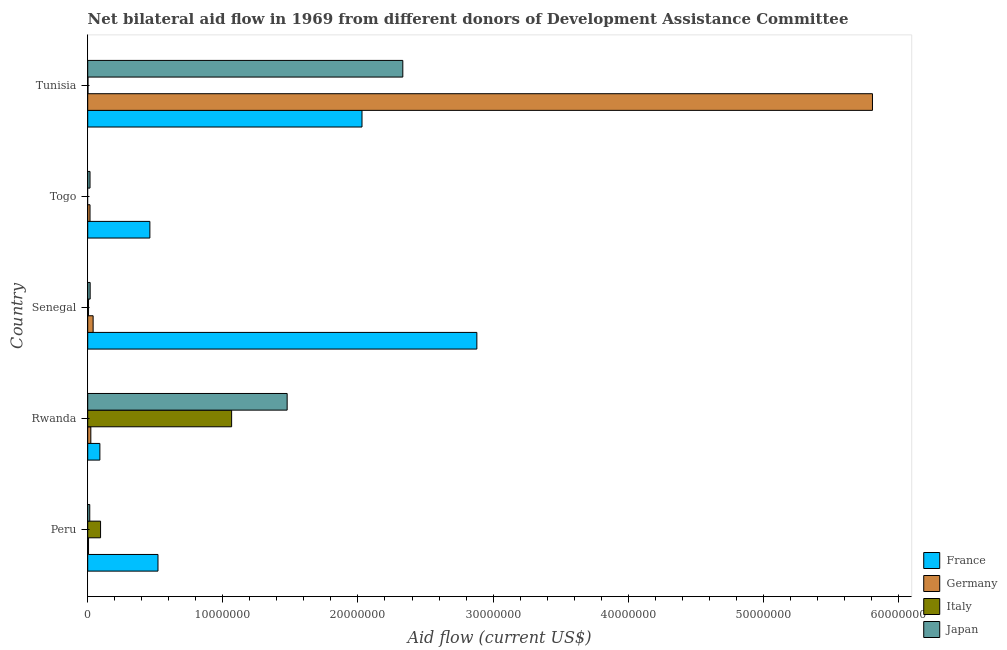How many groups of bars are there?
Your answer should be compact. 5. Are the number of bars per tick equal to the number of legend labels?
Make the answer very short. No. What is the label of the 4th group of bars from the top?
Provide a succinct answer. Rwanda. What is the amount of aid given by japan in Rwanda?
Make the answer very short. 1.48e+07. Across all countries, what is the maximum amount of aid given by japan?
Give a very brief answer. 2.33e+07. Across all countries, what is the minimum amount of aid given by france?
Your answer should be very brief. 9.00e+05. In which country was the amount of aid given by france maximum?
Keep it short and to the point. Senegal. What is the total amount of aid given by france in the graph?
Offer a very short reply. 5.98e+07. What is the difference between the amount of aid given by italy in Rwanda and that in Tunisia?
Your response must be concise. 1.06e+07. What is the difference between the amount of aid given by italy in Senegal and the amount of aid given by japan in Tunisia?
Give a very brief answer. -2.33e+07. What is the average amount of aid given by france per country?
Your answer should be very brief. 1.20e+07. What is the difference between the amount of aid given by japan and amount of aid given by germany in Tunisia?
Your answer should be compact. -3.48e+07. What is the ratio of the amount of aid given by japan in Senegal to that in Togo?
Keep it short and to the point. 1.06. Is the amount of aid given by japan in Senegal less than that in Tunisia?
Make the answer very short. Yes. What is the difference between the highest and the second highest amount of aid given by france?
Your answer should be very brief. 8.50e+06. What is the difference between the highest and the lowest amount of aid given by germany?
Offer a terse response. 5.80e+07. In how many countries, is the amount of aid given by germany greater than the average amount of aid given by germany taken over all countries?
Ensure brevity in your answer.  1. Is the sum of the amount of aid given by germany in Peru and Senegal greater than the maximum amount of aid given by japan across all countries?
Provide a succinct answer. No. Are all the bars in the graph horizontal?
Offer a terse response. Yes. How many countries are there in the graph?
Provide a short and direct response. 5. Does the graph contain grids?
Your answer should be compact. No. Where does the legend appear in the graph?
Your answer should be very brief. Bottom right. How are the legend labels stacked?
Your response must be concise. Vertical. What is the title of the graph?
Your answer should be compact. Net bilateral aid flow in 1969 from different donors of Development Assistance Committee. What is the label or title of the Y-axis?
Your answer should be very brief. Country. What is the Aid flow (current US$) of France in Peru?
Make the answer very short. 5.20e+06. What is the Aid flow (current US$) of Italy in Peru?
Offer a terse response. 9.50e+05. What is the Aid flow (current US$) of Japan in Peru?
Ensure brevity in your answer.  1.50e+05. What is the Aid flow (current US$) in France in Rwanda?
Offer a very short reply. 9.00e+05. What is the Aid flow (current US$) in Italy in Rwanda?
Your response must be concise. 1.06e+07. What is the Aid flow (current US$) in Japan in Rwanda?
Offer a terse response. 1.48e+07. What is the Aid flow (current US$) in France in Senegal?
Keep it short and to the point. 2.88e+07. What is the Aid flow (current US$) of Germany in Senegal?
Offer a terse response. 4.00e+05. What is the Aid flow (current US$) of France in Togo?
Offer a very short reply. 4.60e+06. What is the Aid flow (current US$) of Japan in Togo?
Offer a very short reply. 1.70e+05. What is the Aid flow (current US$) of France in Tunisia?
Provide a succinct answer. 2.03e+07. What is the Aid flow (current US$) of Germany in Tunisia?
Offer a terse response. 5.81e+07. What is the Aid flow (current US$) of Japan in Tunisia?
Make the answer very short. 2.33e+07. Across all countries, what is the maximum Aid flow (current US$) in France?
Keep it short and to the point. 2.88e+07. Across all countries, what is the maximum Aid flow (current US$) of Germany?
Provide a short and direct response. 5.81e+07. Across all countries, what is the maximum Aid flow (current US$) in Italy?
Ensure brevity in your answer.  1.06e+07. Across all countries, what is the maximum Aid flow (current US$) in Japan?
Make the answer very short. 2.33e+07. Across all countries, what is the minimum Aid flow (current US$) in France?
Give a very brief answer. 9.00e+05. Across all countries, what is the minimum Aid flow (current US$) in Germany?
Your answer should be compact. 6.00e+04. Across all countries, what is the minimum Aid flow (current US$) of Italy?
Your answer should be very brief. 0. What is the total Aid flow (current US$) in France in the graph?
Offer a terse response. 5.98e+07. What is the total Aid flow (current US$) of Germany in the graph?
Your answer should be very brief. 5.89e+07. What is the total Aid flow (current US$) of Italy in the graph?
Make the answer very short. 1.17e+07. What is the total Aid flow (current US$) in Japan in the graph?
Offer a terse response. 3.86e+07. What is the difference between the Aid flow (current US$) of France in Peru and that in Rwanda?
Offer a terse response. 4.30e+06. What is the difference between the Aid flow (current US$) in Italy in Peru and that in Rwanda?
Offer a very short reply. -9.70e+06. What is the difference between the Aid flow (current US$) in Japan in Peru and that in Rwanda?
Give a very brief answer. -1.46e+07. What is the difference between the Aid flow (current US$) in France in Peru and that in Senegal?
Offer a terse response. -2.36e+07. What is the difference between the Aid flow (current US$) in Italy in Peru and that in Senegal?
Your response must be concise. 8.90e+05. What is the difference between the Aid flow (current US$) of France in Peru and that in Togo?
Keep it short and to the point. 6.00e+05. What is the difference between the Aid flow (current US$) of Japan in Peru and that in Togo?
Offer a very short reply. -2.00e+04. What is the difference between the Aid flow (current US$) in France in Peru and that in Tunisia?
Give a very brief answer. -1.51e+07. What is the difference between the Aid flow (current US$) of Germany in Peru and that in Tunisia?
Provide a short and direct response. -5.80e+07. What is the difference between the Aid flow (current US$) of Italy in Peru and that in Tunisia?
Your answer should be compact. 9.30e+05. What is the difference between the Aid flow (current US$) in Japan in Peru and that in Tunisia?
Your response must be concise. -2.32e+07. What is the difference between the Aid flow (current US$) of France in Rwanda and that in Senegal?
Ensure brevity in your answer.  -2.79e+07. What is the difference between the Aid flow (current US$) in Italy in Rwanda and that in Senegal?
Give a very brief answer. 1.06e+07. What is the difference between the Aid flow (current US$) of Japan in Rwanda and that in Senegal?
Offer a terse response. 1.46e+07. What is the difference between the Aid flow (current US$) of France in Rwanda and that in Togo?
Provide a succinct answer. -3.70e+06. What is the difference between the Aid flow (current US$) of Japan in Rwanda and that in Togo?
Provide a short and direct response. 1.46e+07. What is the difference between the Aid flow (current US$) in France in Rwanda and that in Tunisia?
Offer a very short reply. -1.94e+07. What is the difference between the Aid flow (current US$) in Germany in Rwanda and that in Tunisia?
Your answer should be very brief. -5.78e+07. What is the difference between the Aid flow (current US$) in Italy in Rwanda and that in Tunisia?
Provide a succinct answer. 1.06e+07. What is the difference between the Aid flow (current US$) of Japan in Rwanda and that in Tunisia?
Offer a very short reply. -8.56e+06. What is the difference between the Aid flow (current US$) of France in Senegal and that in Togo?
Your answer should be compact. 2.42e+07. What is the difference between the Aid flow (current US$) in Germany in Senegal and that in Togo?
Your answer should be very brief. 2.30e+05. What is the difference between the Aid flow (current US$) of France in Senegal and that in Tunisia?
Offer a very short reply. 8.50e+06. What is the difference between the Aid flow (current US$) of Germany in Senegal and that in Tunisia?
Provide a succinct answer. -5.77e+07. What is the difference between the Aid flow (current US$) in Japan in Senegal and that in Tunisia?
Offer a very short reply. -2.31e+07. What is the difference between the Aid flow (current US$) in France in Togo and that in Tunisia?
Provide a short and direct response. -1.57e+07. What is the difference between the Aid flow (current US$) of Germany in Togo and that in Tunisia?
Your answer should be very brief. -5.79e+07. What is the difference between the Aid flow (current US$) of Japan in Togo and that in Tunisia?
Ensure brevity in your answer.  -2.32e+07. What is the difference between the Aid flow (current US$) of France in Peru and the Aid flow (current US$) of Germany in Rwanda?
Give a very brief answer. 4.97e+06. What is the difference between the Aid flow (current US$) in France in Peru and the Aid flow (current US$) in Italy in Rwanda?
Make the answer very short. -5.45e+06. What is the difference between the Aid flow (current US$) in France in Peru and the Aid flow (current US$) in Japan in Rwanda?
Keep it short and to the point. -9.56e+06. What is the difference between the Aid flow (current US$) in Germany in Peru and the Aid flow (current US$) in Italy in Rwanda?
Ensure brevity in your answer.  -1.06e+07. What is the difference between the Aid flow (current US$) of Germany in Peru and the Aid flow (current US$) of Japan in Rwanda?
Give a very brief answer. -1.47e+07. What is the difference between the Aid flow (current US$) in Italy in Peru and the Aid flow (current US$) in Japan in Rwanda?
Offer a terse response. -1.38e+07. What is the difference between the Aid flow (current US$) of France in Peru and the Aid flow (current US$) of Germany in Senegal?
Keep it short and to the point. 4.80e+06. What is the difference between the Aid flow (current US$) in France in Peru and the Aid flow (current US$) in Italy in Senegal?
Provide a succinct answer. 5.14e+06. What is the difference between the Aid flow (current US$) of France in Peru and the Aid flow (current US$) of Japan in Senegal?
Offer a very short reply. 5.02e+06. What is the difference between the Aid flow (current US$) in Germany in Peru and the Aid flow (current US$) in Japan in Senegal?
Your answer should be compact. -1.20e+05. What is the difference between the Aid flow (current US$) of Italy in Peru and the Aid flow (current US$) of Japan in Senegal?
Your answer should be compact. 7.70e+05. What is the difference between the Aid flow (current US$) of France in Peru and the Aid flow (current US$) of Germany in Togo?
Your answer should be very brief. 5.03e+06. What is the difference between the Aid flow (current US$) in France in Peru and the Aid flow (current US$) in Japan in Togo?
Your response must be concise. 5.03e+06. What is the difference between the Aid flow (current US$) of Italy in Peru and the Aid flow (current US$) of Japan in Togo?
Offer a very short reply. 7.80e+05. What is the difference between the Aid flow (current US$) in France in Peru and the Aid flow (current US$) in Germany in Tunisia?
Your answer should be very brief. -5.29e+07. What is the difference between the Aid flow (current US$) in France in Peru and the Aid flow (current US$) in Italy in Tunisia?
Your answer should be compact. 5.18e+06. What is the difference between the Aid flow (current US$) in France in Peru and the Aid flow (current US$) in Japan in Tunisia?
Offer a very short reply. -1.81e+07. What is the difference between the Aid flow (current US$) of Germany in Peru and the Aid flow (current US$) of Japan in Tunisia?
Keep it short and to the point. -2.33e+07. What is the difference between the Aid flow (current US$) of Italy in Peru and the Aid flow (current US$) of Japan in Tunisia?
Your answer should be very brief. -2.24e+07. What is the difference between the Aid flow (current US$) of France in Rwanda and the Aid flow (current US$) of Germany in Senegal?
Provide a succinct answer. 5.00e+05. What is the difference between the Aid flow (current US$) of France in Rwanda and the Aid flow (current US$) of Italy in Senegal?
Provide a succinct answer. 8.40e+05. What is the difference between the Aid flow (current US$) of France in Rwanda and the Aid flow (current US$) of Japan in Senegal?
Give a very brief answer. 7.20e+05. What is the difference between the Aid flow (current US$) of Italy in Rwanda and the Aid flow (current US$) of Japan in Senegal?
Provide a short and direct response. 1.05e+07. What is the difference between the Aid flow (current US$) of France in Rwanda and the Aid flow (current US$) of Germany in Togo?
Provide a succinct answer. 7.30e+05. What is the difference between the Aid flow (current US$) in France in Rwanda and the Aid flow (current US$) in Japan in Togo?
Give a very brief answer. 7.30e+05. What is the difference between the Aid flow (current US$) of Germany in Rwanda and the Aid flow (current US$) of Japan in Togo?
Provide a succinct answer. 6.00e+04. What is the difference between the Aid flow (current US$) of Italy in Rwanda and the Aid flow (current US$) of Japan in Togo?
Provide a short and direct response. 1.05e+07. What is the difference between the Aid flow (current US$) of France in Rwanda and the Aid flow (current US$) of Germany in Tunisia?
Your answer should be compact. -5.72e+07. What is the difference between the Aid flow (current US$) of France in Rwanda and the Aid flow (current US$) of Italy in Tunisia?
Provide a short and direct response. 8.80e+05. What is the difference between the Aid flow (current US$) in France in Rwanda and the Aid flow (current US$) in Japan in Tunisia?
Your answer should be very brief. -2.24e+07. What is the difference between the Aid flow (current US$) of Germany in Rwanda and the Aid flow (current US$) of Japan in Tunisia?
Provide a succinct answer. -2.31e+07. What is the difference between the Aid flow (current US$) of Italy in Rwanda and the Aid flow (current US$) of Japan in Tunisia?
Offer a very short reply. -1.27e+07. What is the difference between the Aid flow (current US$) in France in Senegal and the Aid flow (current US$) in Germany in Togo?
Make the answer very short. 2.86e+07. What is the difference between the Aid flow (current US$) of France in Senegal and the Aid flow (current US$) of Japan in Togo?
Your response must be concise. 2.86e+07. What is the difference between the Aid flow (current US$) of Germany in Senegal and the Aid flow (current US$) of Japan in Togo?
Offer a very short reply. 2.30e+05. What is the difference between the Aid flow (current US$) in Italy in Senegal and the Aid flow (current US$) in Japan in Togo?
Give a very brief answer. -1.10e+05. What is the difference between the Aid flow (current US$) in France in Senegal and the Aid flow (current US$) in Germany in Tunisia?
Your response must be concise. -2.93e+07. What is the difference between the Aid flow (current US$) of France in Senegal and the Aid flow (current US$) of Italy in Tunisia?
Make the answer very short. 2.88e+07. What is the difference between the Aid flow (current US$) of France in Senegal and the Aid flow (current US$) of Japan in Tunisia?
Your answer should be compact. 5.48e+06. What is the difference between the Aid flow (current US$) of Germany in Senegal and the Aid flow (current US$) of Japan in Tunisia?
Your answer should be compact. -2.29e+07. What is the difference between the Aid flow (current US$) of Italy in Senegal and the Aid flow (current US$) of Japan in Tunisia?
Keep it short and to the point. -2.33e+07. What is the difference between the Aid flow (current US$) of France in Togo and the Aid flow (current US$) of Germany in Tunisia?
Make the answer very short. -5.35e+07. What is the difference between the Aid flow (current US$) of France in Togo and the Aid flow (current US$) of Italy in Tunisia?
Provide a short and direct response. 4.58e+06. What is the difference between the Aid flow (current US$) of France in Togo and the Aid flow (current US$) of Japan in Tunisia?
Offer a very short reply. -1.87e+07. What is the difference between the Aid flow (current US$) of Germany in Togo and the Aid flow (current US$) of Japan in Tunisia?
Ensure brevity in your answer.  -2.32e+07. What is the average Aid flow (current US$) of France per country?
Offer a very short reply. 1.20e+07. What is the average Aid flow (current US$) in Germany per country?
Keep it short and to the point. 1.18e+07. What is the average Aid flow (current US$) of Italy per country?
Ensure brevity in your answer.  2.34e+06. What is the average Aid flow (current US$) in Japan per country?
Your answer should be compact. 7.72e+06. What is the difference between the Aid flow (current US$) of France and Aid flow (current US$) of Germany in Peru?
Make the answer very short. 5.14e+06. What is the difference between the Aid flow (current US$) of France and Aid flow (current US$) of Italy in Peru?
Your response must be concise. 4.25e+06. What is the difference between the Aid flow (current US$) in France and Aid flow (current US$) in Japan in Peru?
Make the answer very short. 5.05e+06. What is the difference between the Aid flow (current US$) of Germany and Aid flow (current US$) of Italy in Peru?
Offer a very short reply. -8.90e+05. What is the difference between the Aid flow (current US$) in Italy and Aid flow (current US$) in Japan in Peru?
Keep it short and to the point. 8.00e+05. What is the difference between the Aid flow (current US$) of France and Aid flow (current US$) of Germany in Rwanda?
Offer a terse response. 6.70e+05. What is the difference between the Aid flow (current US$) in France and Aid flow (current US$) in Italy in Rwanda?
Provide a short and direct response. -9.75e+06. What is the difference between the Aid flow (current US$) in France and Aid flow (current US$) in Japan in Rwanda?
Provide a short and direct response. -1.39e+07. What is the difference between the Aid flow (current US$) in Germany and Aid flow (current US$) in Italy in Rwanda?
Give a very brief answer. -1.04e+07. What is the difference between the Aid flow (current US$) in Germany and Aid flow (current US$) in Japan in Rwanda?
Provide a succinct answer. -1.45e+07. What is the difference between the Aid flow (current US$) of Italy and Aid flow (current US$) of Japan in Rwanda?
Ensure brevity in your answer.  -4.11e+06. What is the difference between the Aid flow (current US$) of France and Aid flow (current US$) of Germany in Senegal?
Ensure brevity in your answer.  2.84e+07. What is the difference between the Aid flow (current US$) of France and Aid flow (current US$) of Italy in Senegal?
Your answer should be very brief. 2.87e+07. What is the difference between the Aid flow (current US$) of France and Aid flow (current US$) of Japan in Senegal?
Ensure brevity in your answer.  2.86e+07. What is the difference between the Aid flow (current US$) of Germany and Aid flow (current US$) of Italy in Senegal?
Give a very brief answer. 3.40e+05. What is the difference between the Aid flow (current US$) of Germany and Aid flow (current US$) of Japan in Senegal?
Ensure brevity in your answer.  2.20e+05. What is the difference between the Aid flow (current US$) of Italy and Aid flow (current US$) of Japan in Senegal?
Keep it short and to the point. -1.20e+05. What is the difference between the Aid flow (current US$) of France and Aid flow (current US$) of Germany in Togo?
Your answer should be very brief. 4.43e+06. What is the difference between the Aid flow (current US$) in France and Aid flow (current US$) in Japan in Togo?
Your answer should be very brief. 4.43e+06. What is the difference between the Aid flow (current US$) of Germany and Aid flow (current US$) of Japan in Togo?
Offer a terse response. 0. What is the difference between the Aid flow (current US$) in France and Aid flow (current US$) in Germany in Tunisia?
Your answer should be compact. -3.78e+07. What is the difference between the Aid flow (current US$) of France and Aid flow (current US$) of Italy in Tunisia?
Provide a short and direct response. 2.03e+07. What is the difference between the Aid flow (current US$) in France and Aid flow (current US$) in Japan in Tunisia?
Make the answer very short. -3.02e+06. What is the difference between the Aid flow (current US$) of Germany and Aid flow (current US$) of Italy in Tunisia?
Your answer should be compact. 5.81e+07. What is the difference between the Aid flow (current US$) of Germany and Aid flow (current US$) of Japan in Tunisia?
Keep it short and to the point. 3.48e+07. What is the difference between the Aid flow (current US$) in Italy and Aid flow (current US$) in Japan in Tunisia?
Offer a very short reply. -2.33e+07. What is the ratio of the Aid flow (current US$) of France in Peru to that in Rwanda?
Ensure brevity in your answer.  5.78. What is the ratio of the Aid flow (current US$) in Germany in Peru to that in Rwanda?
Keep it short and to the point. 0.26. What is the ratio of the Aid flow (current US$) in Italy in Peru to that in Rwanda?
Offer a very short reply. 0.09. What is the ratio of the Aid flow (current US$) of Japan in Peru to that in Rwanda?
Offer a terse response. 0.01. What is the ratio of the Aid flow (current US$) of France in Peru to that in Senegal?
Offer a terse response. 0.18. What is the ratio of the Aid flow (current US$) in Italy in Peru to that in Senegal?
Keep it short and to the point. 15.83. What is the ratio of the Aid flow (current US$) in France in Peru to that in Togo?
Ensure brevity in your answer.  1.13. What is the ratio of the Aid flow (current US$) of Germany in Peru to that in Togo?
Offer a very short reply. 0.35. What is the ratio of the Aid flow (current US$) in Japan in Peru to that in Togo?
Offer a terse response. 0.88. What is the ratio of the Aid flow (current US$) of France in Peru to that in Tunisia?
Your answer should be compact. 0.26. What is the ratio of the Aid flow (current US$) in Italy in Peru to that in Tunisia?
Your answer should be compact. 47.5. What is the ratio of the Aid flow (current US$) of Japan in Peru to that in Tunisia?
Your answer should be very brief. 0.01. What is the ratio of the Aid flow (current US$) of France in Rwanda to that in Senegal?
Offer a terse response. 0.03. What is the ratio of the Aid flow (current US$) in Germany in Rwanda to that in Senegal?
Your response must be concise. 0.57. What is the ratio of the Aid flow (current US$) in Italy in Rwanda to that in Senegal?
Offer a terse response. 177.5. What is the ratio of the Aid flow (current US$) in Japan in Rwanda to that in Senegal?
Your answer should be very brief. 82. What is the ratio of the Aid flow (current US$) in France in Rwanda to that in Togo?
Give a very brief answer. 0.2. What is the ratio of the Aid flow (current US$) in Germany in Rwanda to that in Togo?
Give a very brief answer. 1.35. What is the ratio of the Aid flow (current US$) in Japan in Rwanda to that in Togo?
Offer a terse response. 86.82. What is the ratio of the Aid flow (current US$) of France in Rwanda to that in Tunisia?
Offer a terse response. 0.04. What is the ratio of the Aid flow (current US$) of Germany in Rwanda to that in Tunisia?
Your answer should be compact. 0. What is the ratio of the Aid flow (current US$) of Italy in Rwanda to that in Tunisia?
Your answer should be compact. 532.5. What is the ratio of the Aid flow (current US$) of Japan in Rwanda to that in Tunisia?
Your answer should be compact. 0.63. What is the ratio of the Aid flow (current US$) of France in Senegal to that in Togo?
Give a very brief answer. 6.26. What is the ratio of the Aid flow (current US$) in Germany in Senegal to that in Togo?
Offer a very short reply. 2.35. What is the ratio of the Aid flow (current US$) of Japan in Senegal to that in Togo?
Ensure brevity in your answer.  1.06. What is the ratio of the Aid flow (current US$) in France in Senegal to that in Tunisia?
Your answer should be very brief. 1.42. What is the ratio of the Aid flow (current US$) in Germany in Senegal to that in Tunisia?
Offer a terse response. 0.01. What is the ratio of the Aid flow (current US$) in Japan in Senegal to that in Tunisia?
Give a very brief answer. 0.01. What is the ratio of the Aid flow (current US$) of France in Togo to that in Tunisia?
Your response must be concise. 0.23. What is the ratio of the Aid flow (current US$) in Germany in Togo to that in Tunisia?
Your response must be concise. 0. What is the ratio of the Aid flow (current US$) in Japan in Togo to that in Tunisia?
Give a very brief answer. 0.01. What is the difference between the highest and the second highest Aid flow (current US$) in France?
Offer a very short reply. 8.50e+06. What is the difference between the highest and the second highest Aid flow (current US$) of Germany?
Provide a short and direct response. 5.77e+07. What is the difference between the highest and the second highest Aid flow (current US$) in Italy?
Offer a very short reply. 9.70e+06. What is the difference between the highest and the second highest Aid flow (current US$) of Japan?
Provide a short and direct response. 8.56e+06. What is the difference between the highest and the lowest Aid flow (current US$) of France?
Your response must be concise. 2.79e+07. What is the difference between the highest and the lowest Aid flow (current US$) in Germany?
Keep it short and to the point. 5.80e+07. What is the difference between the highest and the lowest Aid flow (current US$) of Italy?
Offer a terse response. 1.06e+07. What is the difference between the highest and the lowest Aid flow (current US$) in Japan?
Offer a terse response. 2.32e+07. 